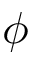<formula> <loc_0><loc_0><loc_500><loc_500>\phi</formula> 